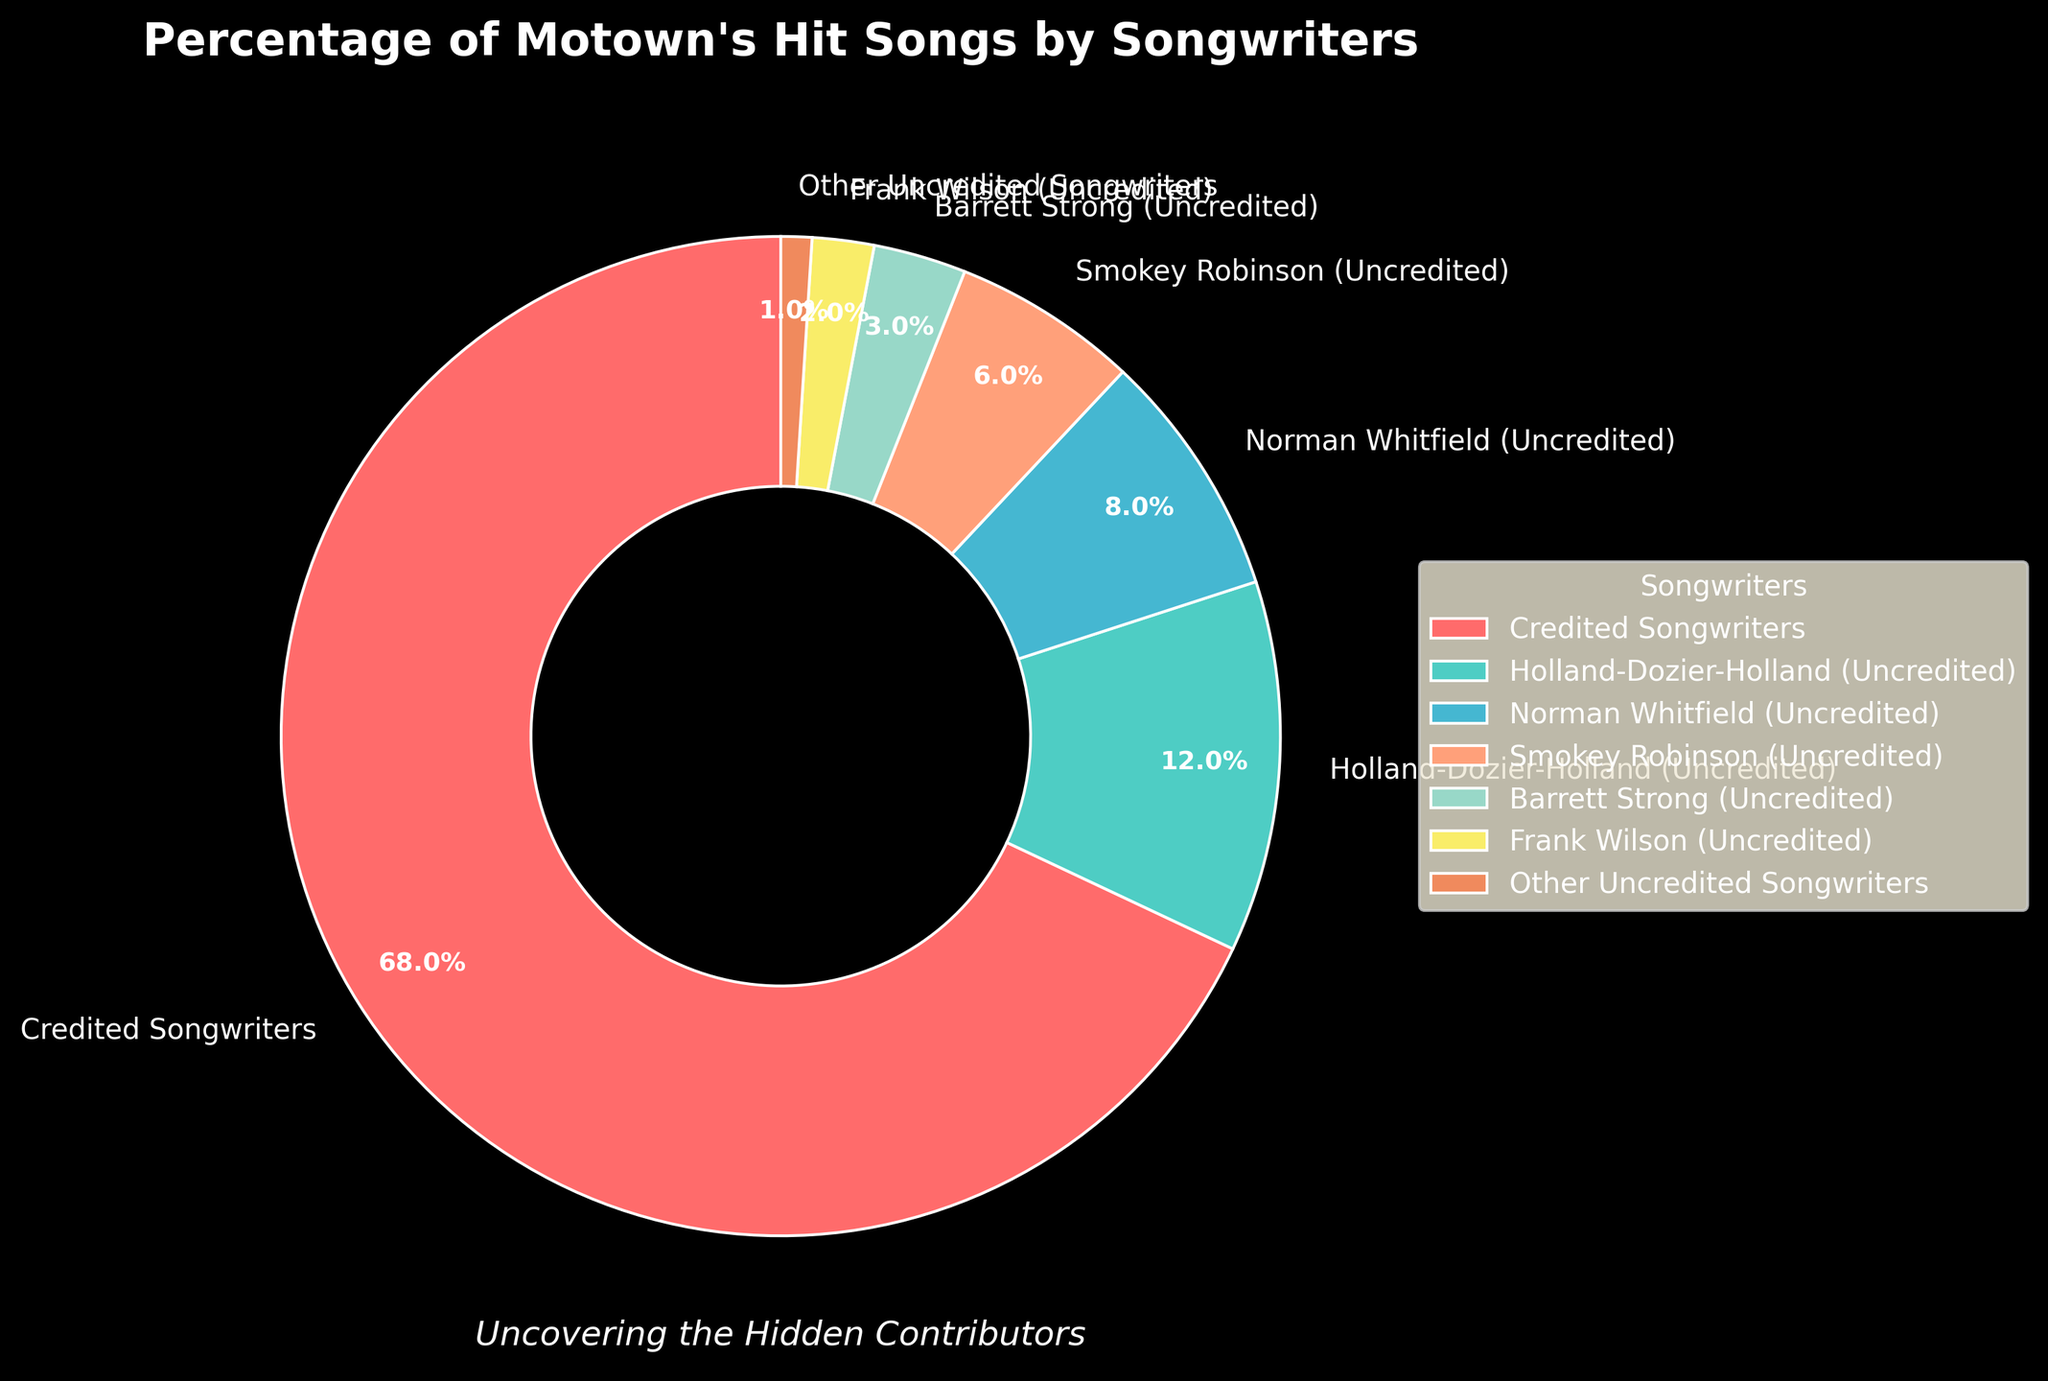what percentage of Motown's hit songs were written by uncredited songwriters in total? Sum the percentages of all uncredited songwriters: 12% (Holland-Dozier-Holland) + 8% (Norman Whitfield) + 6% (Smokey Robinson) + 3% (Barrett Strong) + 2% (Frank Wilson) + 1% (Other Uncredited Songwriters) = 32%
Answer: 32% Which category has the largest share of credited songs? The pie chart shows that the "Credited Songwriters" category has the largest percentage of 68%, which is greater than any other single category.
Answer: Credited Songwriters How does Norman Whitfield's contribution compare to Barrett Strong's? Compare their percentages: Norman Whitfield (8%) has a higher contribution than Barrett Strong (3%).
Answer: Norman Whitfield has a higher contribution What is the combined contribution of Holland-Dozier-Holland and Smokey Robinson? Sum the contributions of Holland-Dozier-Holland (12%) and Smokey Robinson (6%): 12% + 6% = 18%
Answer: 18% What is the smallest category of uncredited songwriters and its percentage? The category "Other Uncredited Songwriters" is the smallest, with a percentage of 1%.
Answer: Other Uncredited Songwriters, 1% What is the difference in percentage between credited songwriters and all uncredited songwriters combined? Calculate the total of uncredited songwriters (32%) and subtract it from the credited songwriters (68%): 68% - 32% = 36%
Answer: 36% Which color represents the Holland-Dozier-Holland category and what is its percentage? Identify the color associated with Holland-Dozier-Holland in the pie chart legend (turquoise green) and its percentage (12%).
Answer: Turquoise green, 12% 